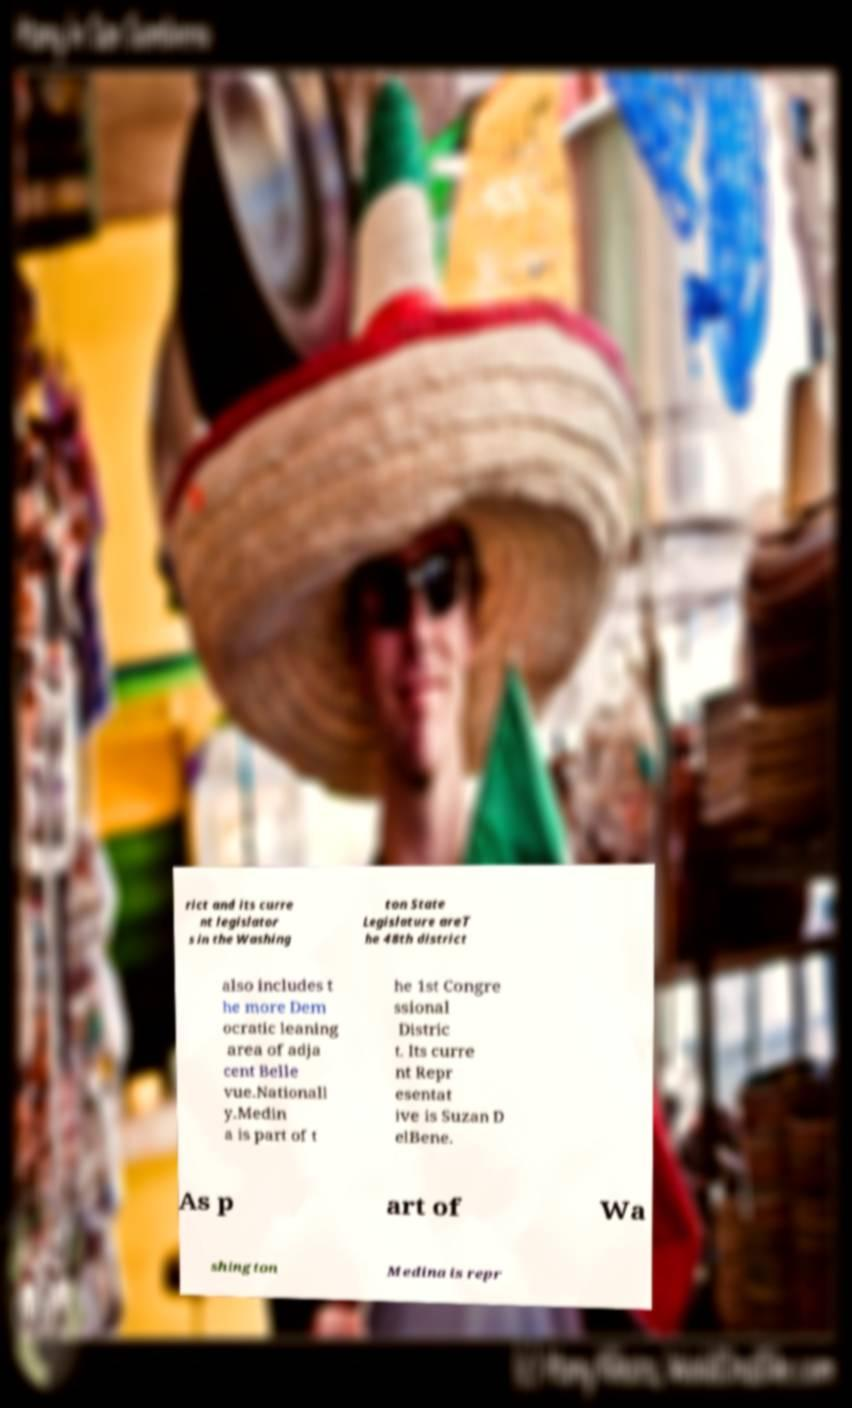What messages or text are displayed in this image? I need them in a readable, typed format. rict and its curre nt legislator s in the Washing ton State Legislature areT he 48th district also includes t he more Dem ocratic leaning area of adja cent Belle vue.Nationall y.Medin a is part of t he 1st Congre ssional Distric t. Its curre nt Repr esentat ive is Suzan D elBene. As p art of Wa shington Medina is repr 